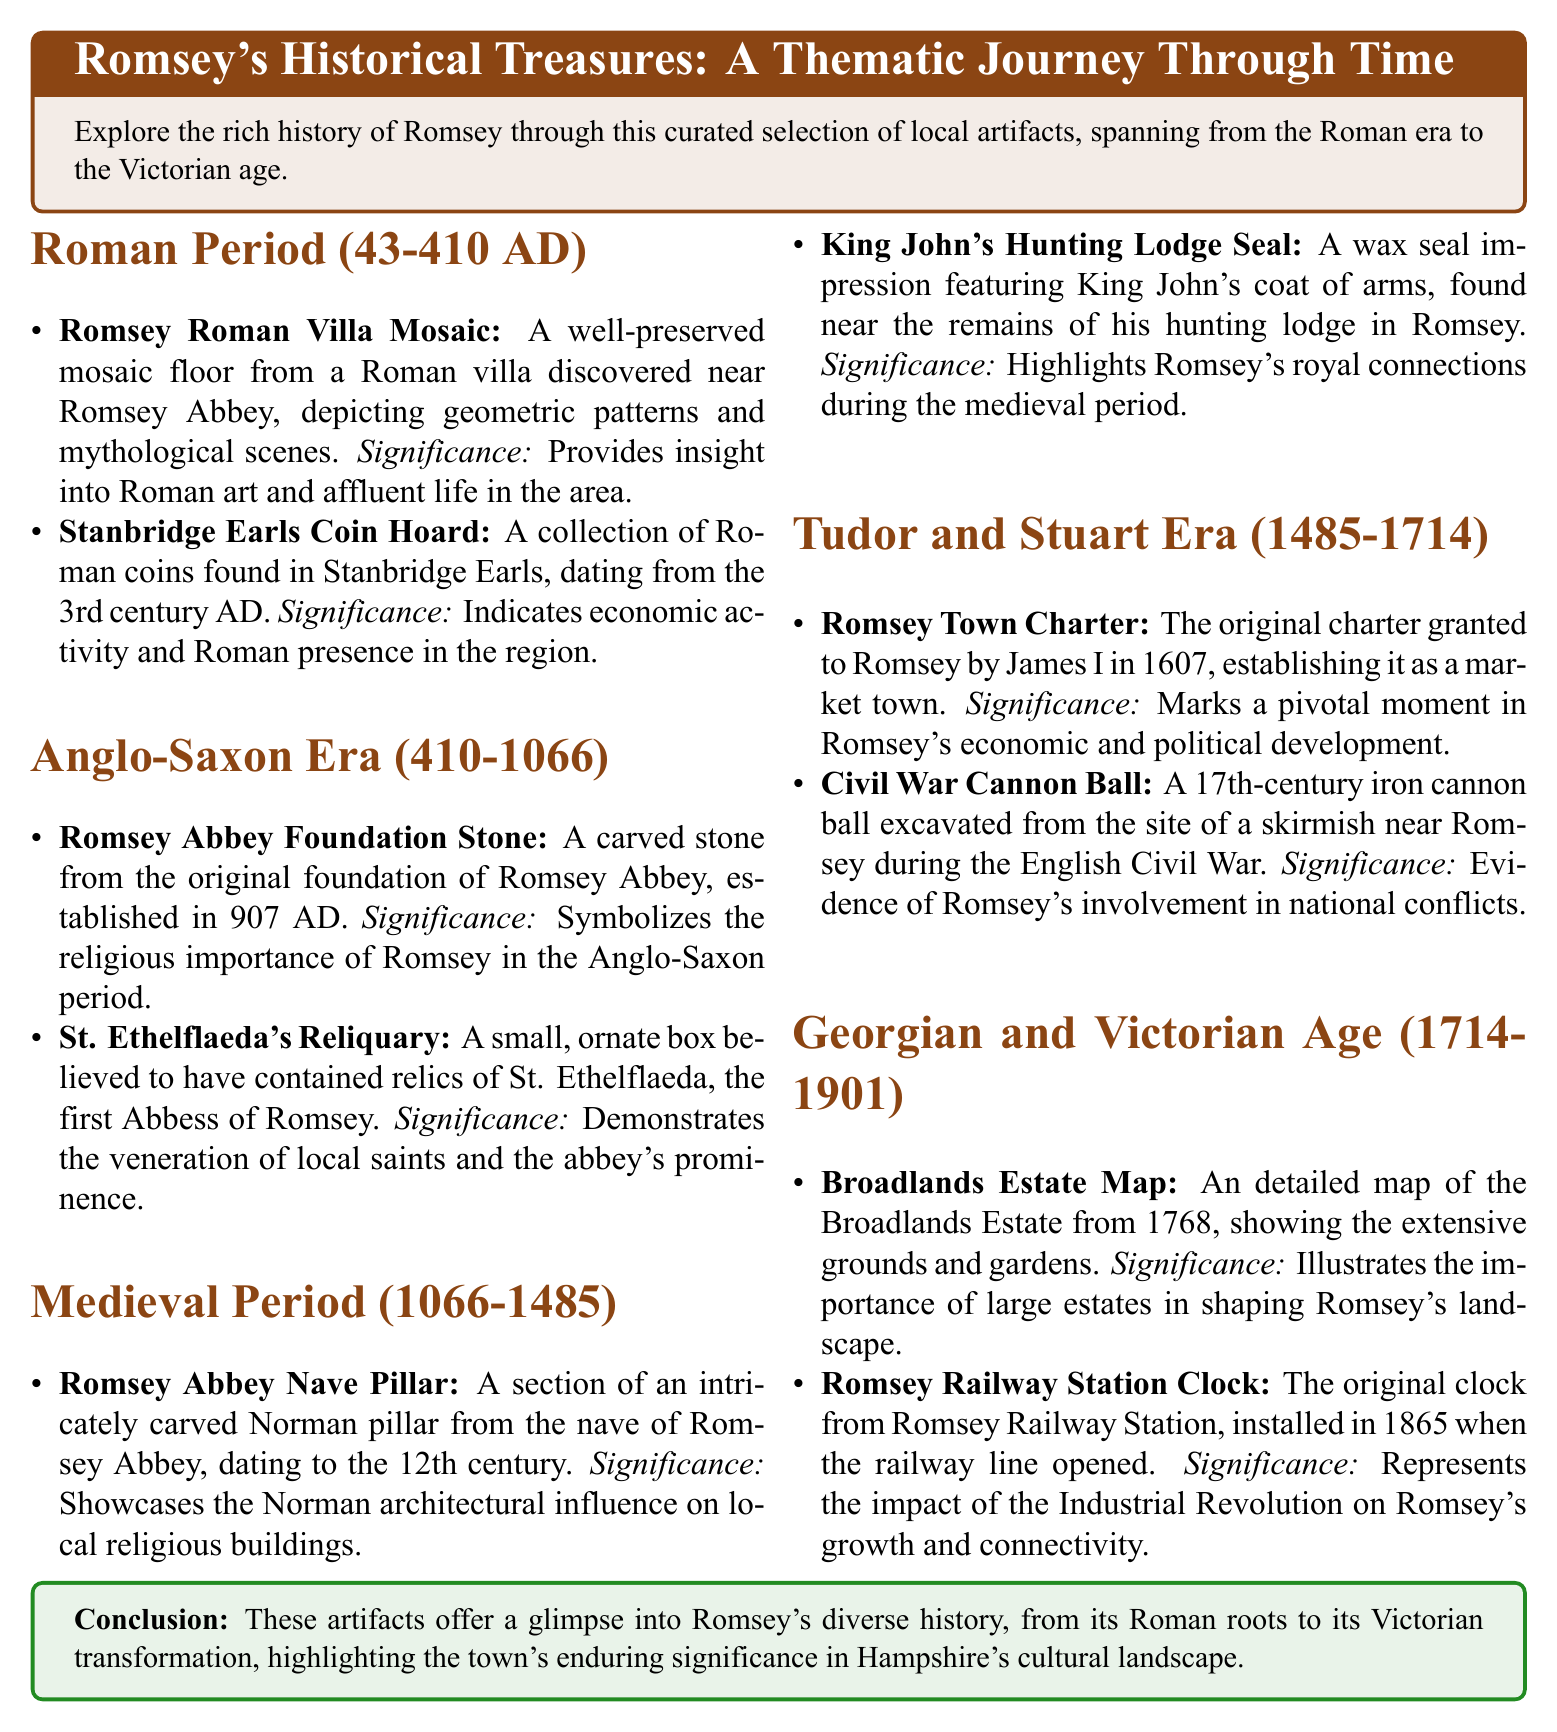What is the Roman period's date range? The date range for the Roman period in the document is 43-410 AD.
Answer: 43-410 AD What artifact is associated with St. Ethelflaeda? St. Ethelflaeda's Reliquary is mentioned in relation to her and contains relics believed to be hers.
Answer: St. Ethelflaeda's Reliquary Which artifact showcases Norman architectural influence? The Romsey Abbey Nave Pillar is highlighted as showcasing Norman architectural influence.
Answer: Romsey Abbey Nave Pillar What significant document was granted to Romsey by James I? The Romsey Town Charter was granted to Romsey, establishing it as a market town.
Answer: Romsey Town Charter Which artifact represents the impact of the Industrial Revolution? The Romsey Railway Station Clock represents the impact of the Industrial Revolution on Romsey's growth.
Answer: Romsey Railway Station Clock How many artifacts are listed for the Tudor and Stuart Era? The document lists two artifacts for the Tudor and Stuart Era.
Answer: Two artifacts What year is the Broadlands Estate Map dated? The Broadlands Estate Map is dated from 1768.
Answer: 1768 Which king is mentioned in connection with a seal artifact? King John is mentioned in connection with the King John's Hunting Lodge Seal.
Answer: King John 